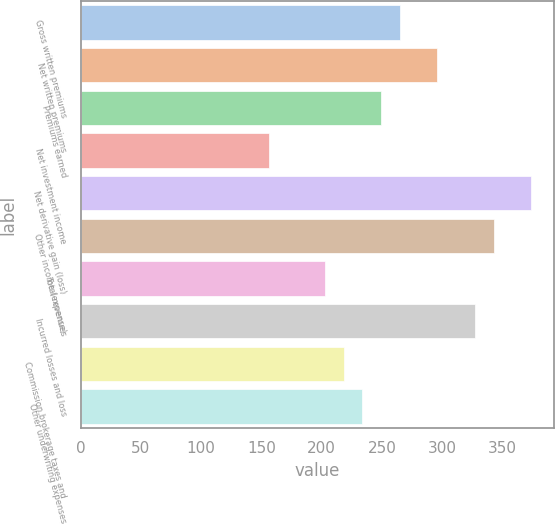Convert chart to OTSL. <chart><loc_0><loc_0><loc_500><loc_500><bar_chart><fcel>Gross written premiums<fcel>Net written premiums<fcel>Premiums earned<fcel>Net investment income<fcel>Net derivative gain (loss)<fcel>Other income (expense)<fcel>Total revenues<fcel>Incurred losses and loss<fcel>Commission brokerage taxes and<fcel>Other underwriting expenses<nl><fcel>264.96<fcel>296.12<fcel>249.38<fcel>155.9<fcel>374.02<fcel>342.86<fcel>202.64<fcel>327.28<fcel>218.22<fcel>233.8<nl></chart> 